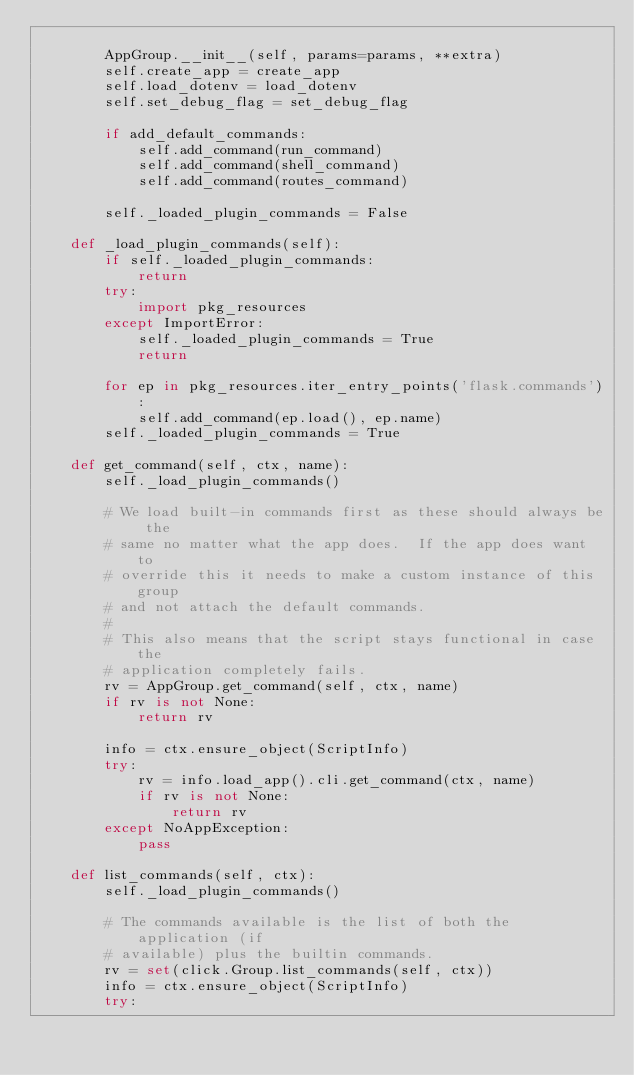Convert code to text. <code><loc_0><loc_0><loc_500><loc_500><_Python_>
        AppGroup.__init__(self, params=params, **extra)
        self.create_app = create_app
        self.load_dotenv = load_dotenv
        self.set_debug_flag = set_debug_flag

        if add_default_commands:
            self.add_command(run_command)
            self.add_command(shell_command)
            self.add_command(routes_command)

        self._loaded_plugin_commands = False

    def _load_plugin_commands(self):
        if self._loaded_plugin_commands:
            return
        try:
            import pkg_resources
        except ImportError:
            self._loaded_plugin_commands = True
            return

        for ep in pkg_resources.iter_entry_points('flask.commands'):
            self.add_command(ep.load(), ep.name)
        self._loaded_plugin_commands = True

    def get_command(self, ctx, name):
        self._load_plugin_commands()

        # We load built-in commands first as these should always be the
        # same no matter what the app does.  If the app does want to
        # override this it needs to make a custom instance of this group
        # and not attach the default commands.
        #
        # This also means that the script stays functional in case the
        # application completely fails.
        rv = AppGroup.get_command(self, ctx, name)
        if rv is not None:
            return rv

        info = ctx.ensure_object(ScriptInfo)
        try:
            rv = info.load_app().cli.get_command(ctx, name)
            if rv is not None:
                return rv
        except NoAppException:
            pass

    def list_commands(self, ctx):
        self._load_plugin_commands()

        # The commands available is the list of both the application (if
        # available) plus the builtin commands.
        rv = set(click.Group.list_commands(self, ctx))
        info = ctx.ensure_object(ScriptInfo)
        try:</code> 